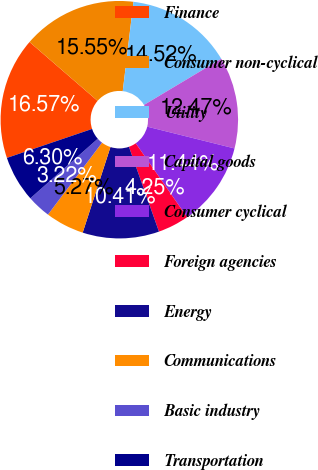Convert chart to OTSL. <chart><loc_0><loc_0><loc_500><loc_500><pie_chart><fcel>Finance<fcel>Consumer non-cyclical<fcel>Utility<fcel>Capital goods<fcel>Consumer cyclical<fcel>Foreign agencies<fcel>Energy<fcel>Communications<fcel>Basic industry<fcel>Transportation<nl><fcel>16.57%<fcel>15.55%<fcel>14.52%<fcel>12.47%<fcel>11.44%<fcel>4.25%<fcel>10.41%<fcel>5.27%<fcel>3.22%<fcel>6.3%<nl></chart> 